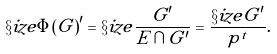<formula> <loc_0><loc_0><loc_500><loc_500>\S i z e { \Phi ( G ) ^ { \prime } } = \S i z e { \frac { G ^ { \prime } } { E \cap G ^ { \prime } } } = \frac { \S i z e { G ^ { \prime } } } { p ^ { t } } .</formula> 